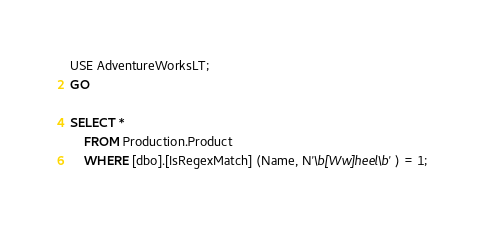<code> <loc_0><loc_0><loc_500><loc_500><_SQL_>USE AdventureWorksLT;
GO

SELECT * 
	FROM Production.Product
	WHERE [dbo].[IsRegexMatch] (Name, N'\b[Ww]heel\b') = 1; 


</code> 